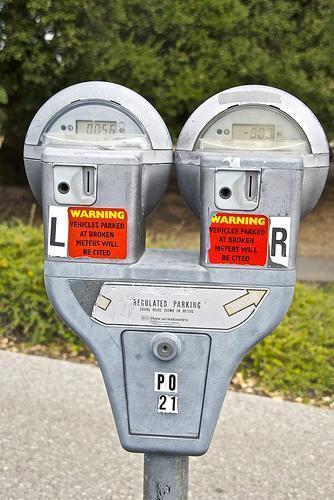How many parking meters are in the photo?
Give a very brief answer. 2. 